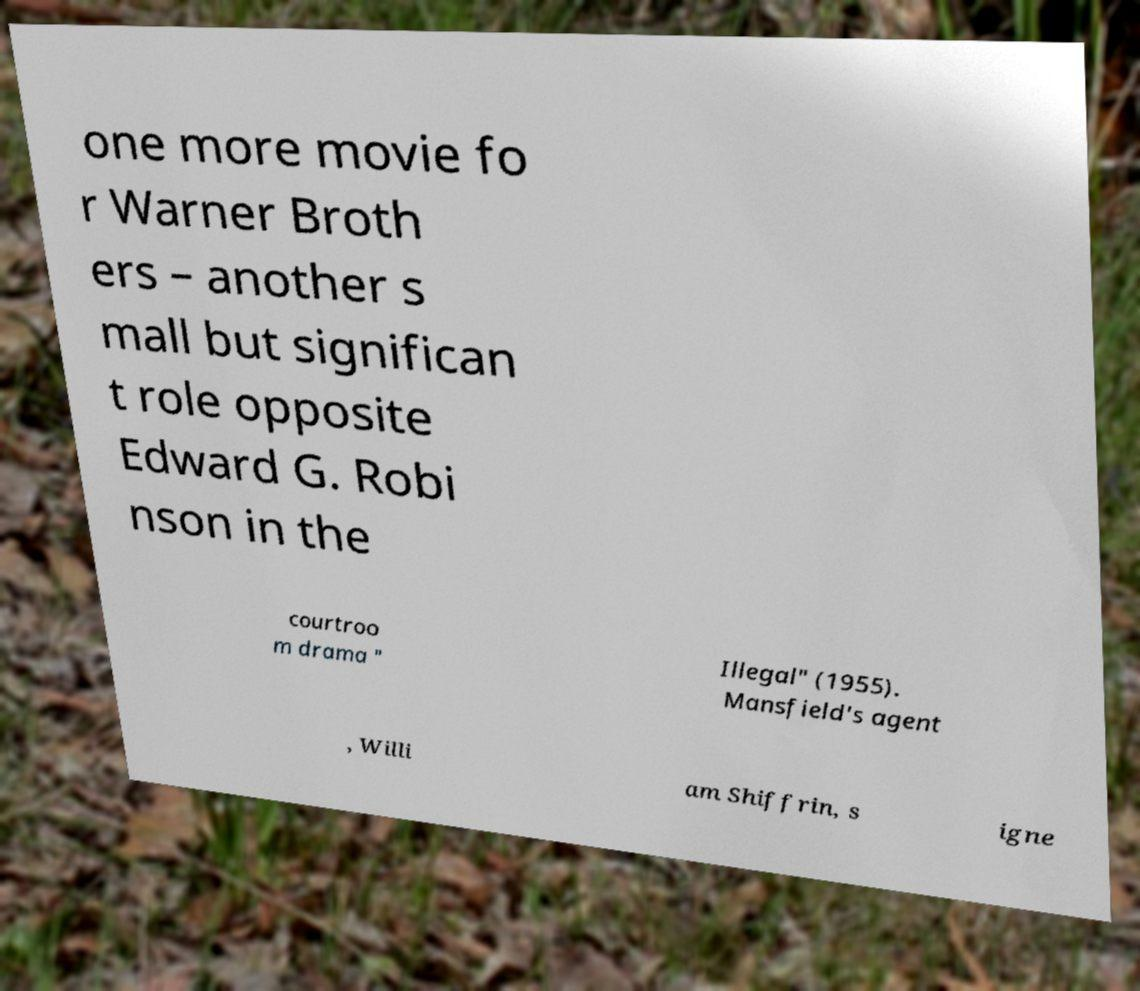For documentation purposes, I need the text within this image transcribed. Could you provide that? one more movie fo r Warner Broth ers – another s mall but significan t role opposite Edward G. Robi nson in the courtroo m drama " Illegal" (1955). Mansfield's agent , Willi am Shiffrin, s igne 